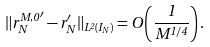<formula> <loc_0><loc_0><loc_500><loc_500>\| { r _ { N } ^ { M , 0 } } ^ { \prime } - r _ { N } ^ { \prime } \| _ { L ^ { 2 } ( I _ { N } ) } = O \left ( \frac { 1 } { M ^ { 1 / 4 } } \right ) .</formula> 